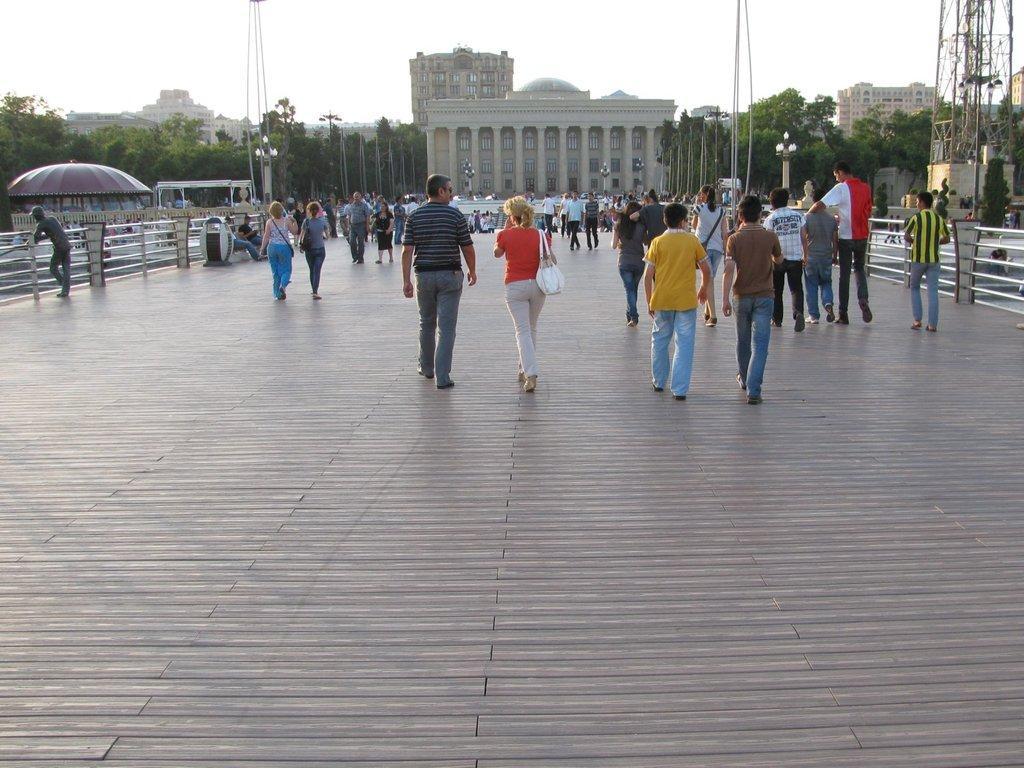In one or two sentences, can you explain what this image depicts? In this image there are persons standing and walking and sitting. In the background there are trees and buildings and there are poles and the sky is cloudy and there are railings. 